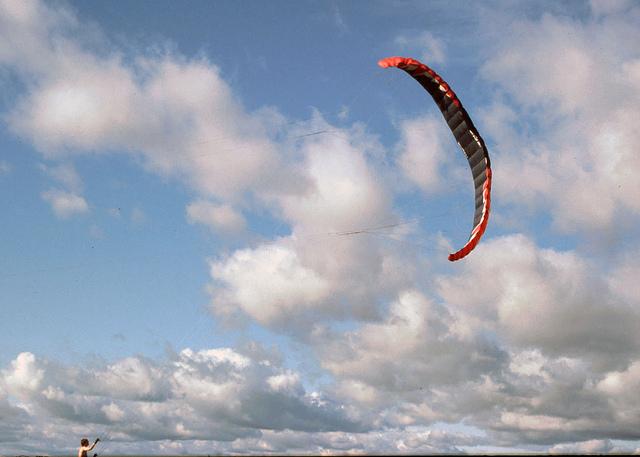Are there clouds visible?
Answer briefly. Yes. What is being flown here?
Be succinct. Kite. Do you see any stars in the sky?
Concise answer only. No. 